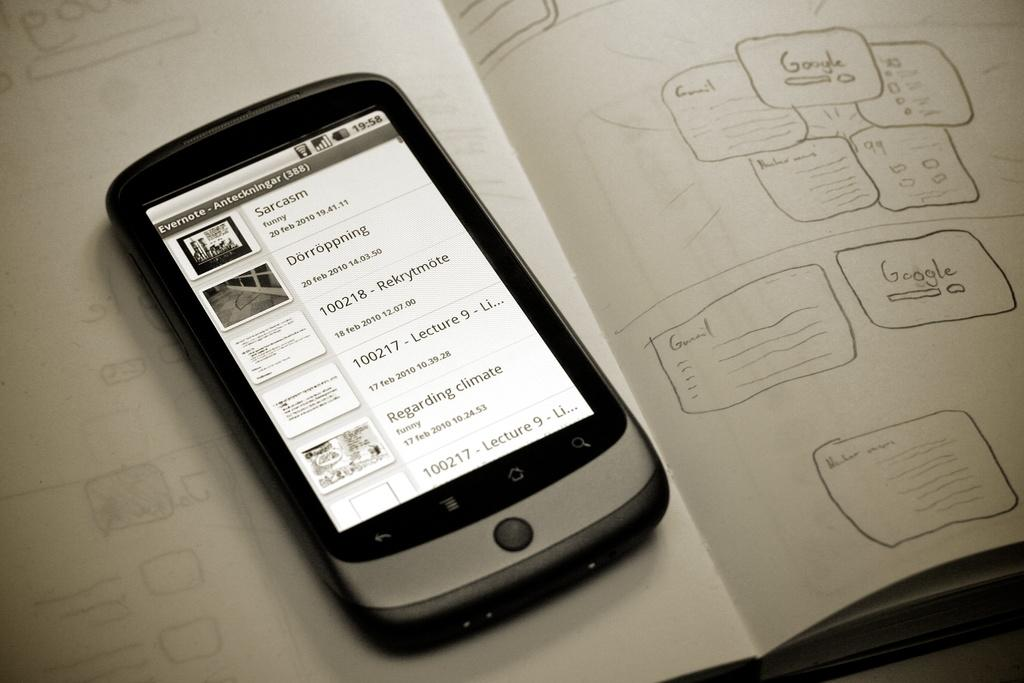Provide a one-sentence caption for the provided image. a small black and silver phone with the word 'sarcasm' on the screen. 